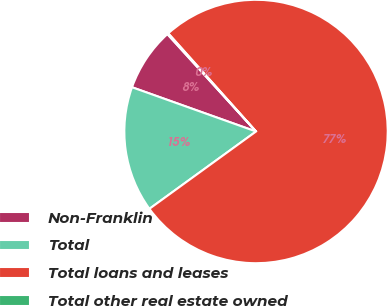<chart> <loc_0><loc_0><loc_500><loc_500><pie_chart><fcel>Non-Franklin<fcel>Total<fcel>Total loans and leases<fcel>Total other real estate owned<nl><fcel>7.79%<fcel>15.44%<fcel>76.62%<fcel>0.14%<nl></chart> 